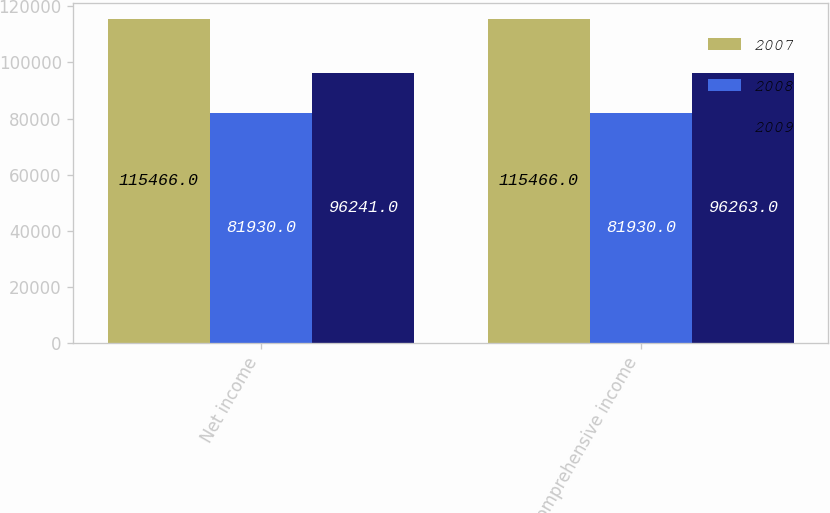<chart> <loc_0><loc_0><loc_500><loc_500><stacked_bar_chart><ecel><fcel>Net income<fcel>Comprehensive income<nl><fcel>2007<fcel>115466<fcel>115466<nl><fcel>2008<fcel>81930<fcel>81930<nl><fcel>2009<fcel>96241<fcel>96263<nl></chart> 